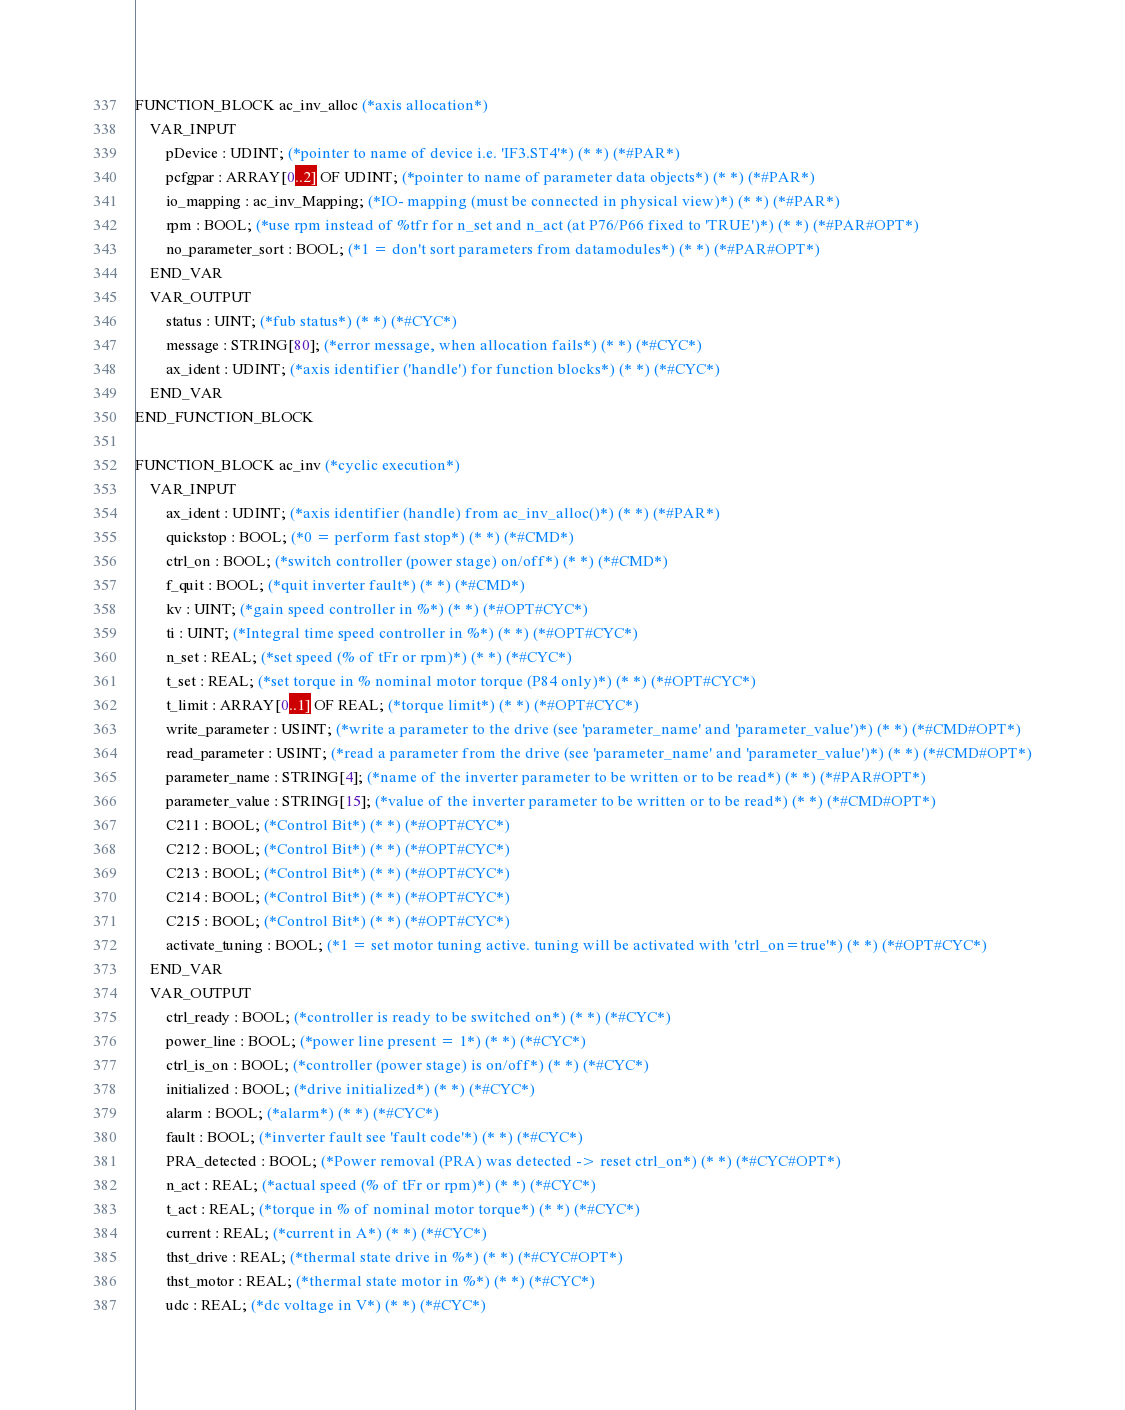Convert code to text. <code><loc_0><loc_0><loc_500><loc_500><_SML_>
FUNCTION_BLOCK ac_inv_alloc (*axis allocation*)
	VAR_INPUT
		pDevice : UDINT; (*pointer to name of device i.e. 'IF3.ST4'*) (* *) (*#PAR*)
		pcfgpar : ARRAY[0..2] OF UDINT; (*pointer to name of parameter data objects*) (* *) (*#PAR*)
		io_mapping : ac_inv_Mapping; (*IO- mapping (must be connected in physical view)*) (* *) (*#PAR*)
		rpm : BOOL; (*use rpm instead of %tfr for n_set and n_act (at P76/P66 fixed to 'TRUE')*) (* *) (*#PAR#OPT*)
		no_parameter_sort : BOOL; (*1 = don't sort parameters from datamodules*) (* *) (*#PAR#OPT*)
	END_VAR
	VAR_OUTPUT
		status : UINT; (*fub status*) (* *) (*#CYC*)
		message : STRING[80]; (*error message, when allocation fails*) (* *) (*#CYC*)
		ax_ident : UDINT; (*axis identifier ('handle') for function blocks*) (* *) (*#CYC*)
	END_VAR
END_FUNCTION_BLOCK

FUNCTION_BLOCK ac_inv (*cyclic execution*)
	VAR_INPUT
		ax_ident : UDINT; (*axis identifier (handle) from ac_inv_alloc()*) (* *) (*#PAR*)
		quickstop : BOOL; (*0 = perform fast stop*) (* *) (*#CMD*)
		ctrl_on : BOOL; (*switch controller (power stage) on/off*) (* *) (*#CMD*)
		f_quit : BOOL; (*quit inverter fault*) (* *) (*#CMD*)
		kv : UINT; (*gain speed controller in %*) (* *) (*#OPT#CYC*)
		ti : UINT; (*Integral time speed controller in %*) (* *) (*#OPT#CYC*)
		n_set : REAL; (*set speed (% of tFr or rpm)*) (* *) (*#CYC*)
		t_set : REAL; (*set torque in % nominal motor torque (P84 only)*) (* *) (*#OPT#CYC*)
		t_limit : ARRAY[0..1] OF REAL; (*torque limit*) (* *) (*#OPT#CYC*)
		write_parameter : USINT; (*write a parameter to the drive (see 'parameter_name' and 'parameter_value')*) (* *) (*#CMD#OPT*)
		read_parameter : USINT; (*read a parameter from the drive (see 'parameter_name' and 'parameter_value')*) (* *) (*#CMD#OPT*)
		parameter_name : STRING[4]; (*name of the inverter parameter to be written or to be read*) (* *) (*#PAR#OPT*)
		parameter_value : STRING[15]; (*value of the inverter parameter to be written or to be read*) (* *) (*#CMD#OPT*)
		C211 : BOOL; (*Control Bit*) (* *) (*#OPT#CYC*)
		C212 : BOOL; (*Control Bit*) (* *) (*#OPT#CYC*)
		C213 : BOOL; (*Control Bit*) (* *) (*#OPT#CYC*)
		C214 : BOOL; (*Control Bit*) (* *) (*#OPT#CYC*)
		C215 : BOOL; (*Control Bit*) (* *) (*#OPT#CYC*)
		activate_tuning : BOOL; (*1 = set motor tuning active. tuning will be activated with 'ctrl_on=true'*) (* *) (*#OPT#CYC*)
	END_VAR
	VAR_OUTPUT
		ctrl_ready : BOOL; (*controller is ready to be switched on*) (* *) (*#CYC*)
		power_line : BOOL; (*power line present = 1*) (* *) (*#CYC*)
		ctrl_is_on : BOOL; (*controller (power stage) is on/off*) (* *) (*#CYC*)
		initialized : BOOL; (*drive initialized*) (* *) (*#CYC*)
		alarm : BOOL; (*alarm*) (* *) (*#CYC*)
		fault : BOOL; (*inverter fault see 'fault code'*) (* *) (*#CYC*)
		PRA_detected : BOOL; (*Power removal (PRA) was detected -> reset ctrl_on*) (* *) (*#CYC#OPT*)
		n_act : REAL; (*actual speed (% of tFr or rpm)*) (* *) (*#CYC*)
		t_act : REAL; (*torque in % of nominal motor torque*) (* *) (*#CYC*)
		current : REAL; (*current in A*) (* *) (*#CYC*)
		thst_drive : REAL; (*thermal state drive in %*) (* *) (*#CYC#OPT*)
		thst_motor : REAL; (*thermal state motor in %*) (* *) (*#CYC*)
		udc : REAL; (*dc voltage in V*) (* *) (*#CYC*)</code> 